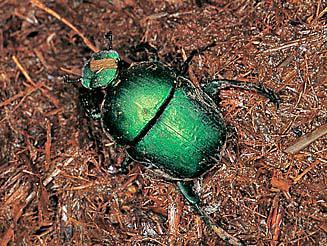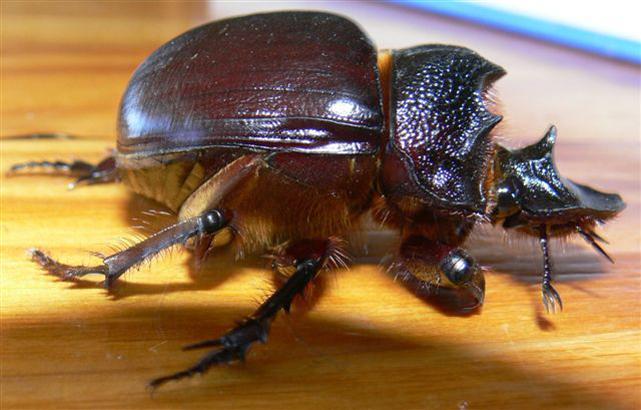The first image is the image on the left, the second image is the image on the right. Analyze the images presented: Is the assertion "There is exactly one insect in the image on the left." valid? Answer yes or no. Yes. 